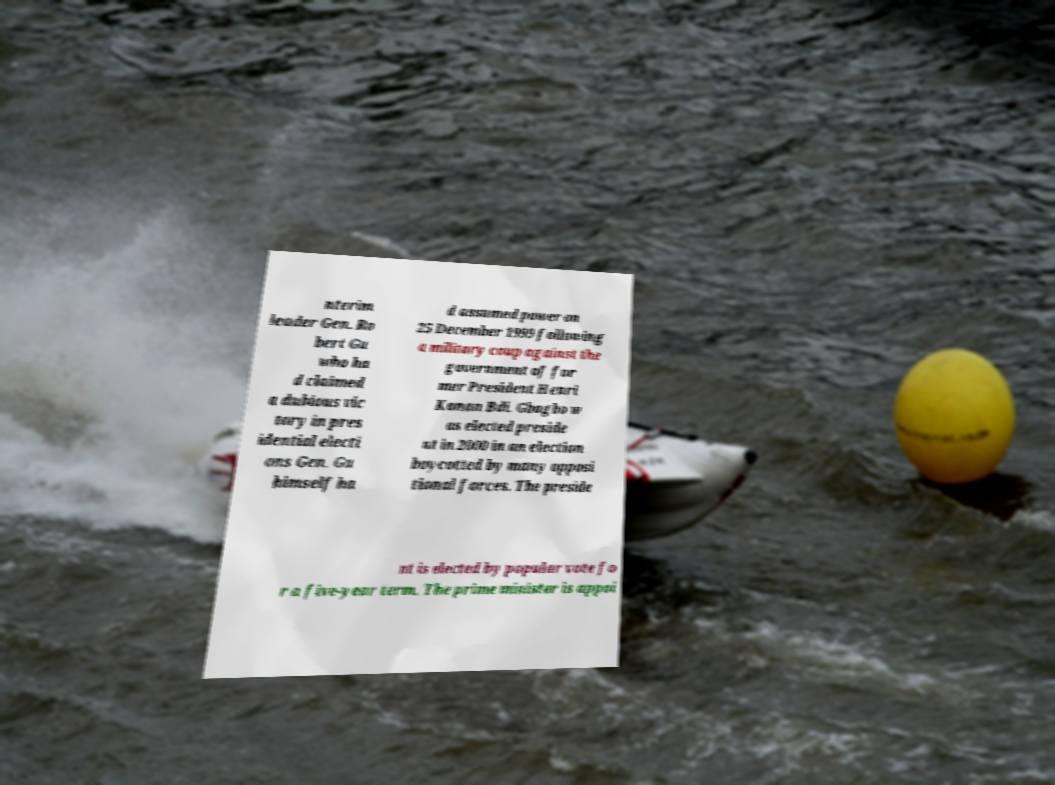There's text embedded in this image that I need extracted. Can you transcribe it verbatim? nterim leader Gen. Ro bert Gu who ha d claimed a dubious vic tory in pres idential electi ons Gen. Gu himself ha d assumed power on 25 December 1999 following a military coup against the government of for mer President Henri Konan Bdi. Gbagbo w as elected preside nt in 2000 in an election boycotted by many opposi tional forces. The preside nt is elected by popular vote fo r a five-year term. The prime minister is appoi 